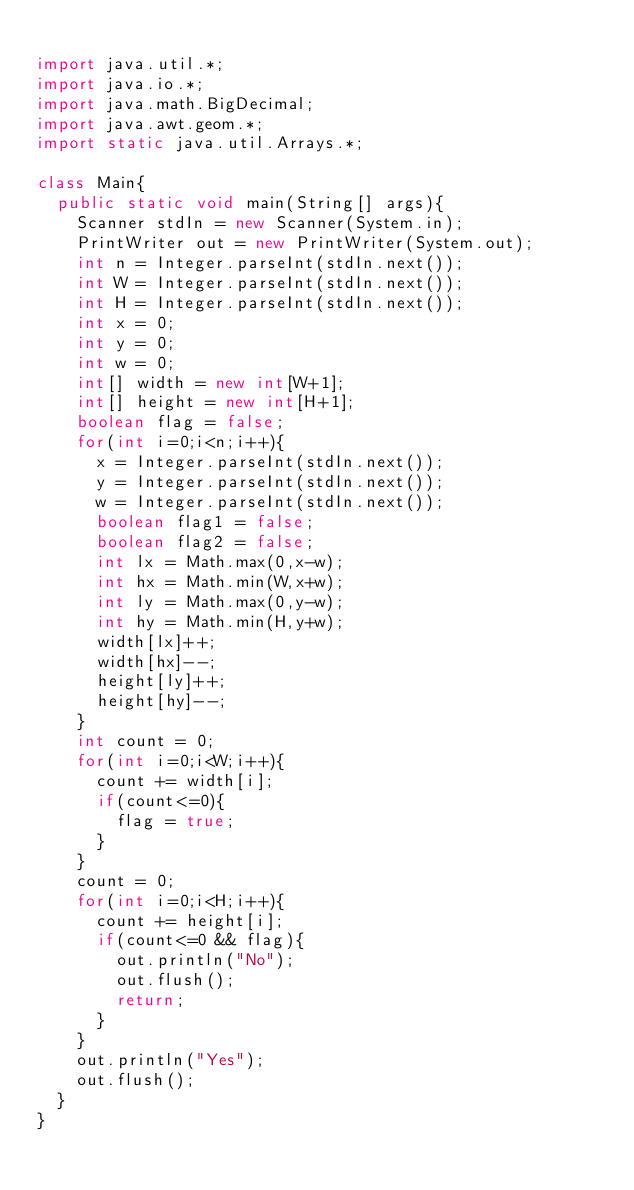<code> <loc_0><loc_0><loc_500><loc_500><_Java_>
import java.util.*;
import java.io.*;
import java.math.BigDecimal;
import java.awt.geom.*;
import static java.util.Arrays.*;

class Main{
	public static void main(String[] args){
		Scanner stdIn = new Scanner(System.in);
		PrintWriter out = new PrintWriter(System.out);
		int n = Integer.parseInt(stdIn.next());
		int W = Integer.parseInt(stdIn.next());
		int H = Integer.parseInt(stdIn.next());
		int x = 0;
		int y = 0;
		int w = 0;
		int[] width = new int[W+1];
		int[] height = new int[H+1];
		boolean flag = false;
		for(int i=0;i<n;i++){
			x = Integer.parseInt(stdIn.next());
			y = Integer.parseInt(stdIn.next());
			w = Integer.parseInt(stdIn.next());
			boolean flag1 = false;
			boolean flag2 = false;
			int lx = Math.max(0,x-w);
			int hx = Math.min(W,x+w);
			int ly = Math.max(0,y-w);
			int hy = Math.min(H,y+w);
			width[lx]++;
			width[hx]--;
			height[ly]++;
			height[hy]--;
		}
		int count = 0;
		for(int i=0;i<W;i++){
			count += width[i];
			if(count<=0){
				flag = true;
			}
		}
		count = 0;
		for(int i=0;i<H;i++){
			count += height[i];
			if(count<=0 && flag){
				out.println("No");
				out.flush();
				return;
			}
		}
		out.println("Yes");
		out.flush();
	}
}</code> 